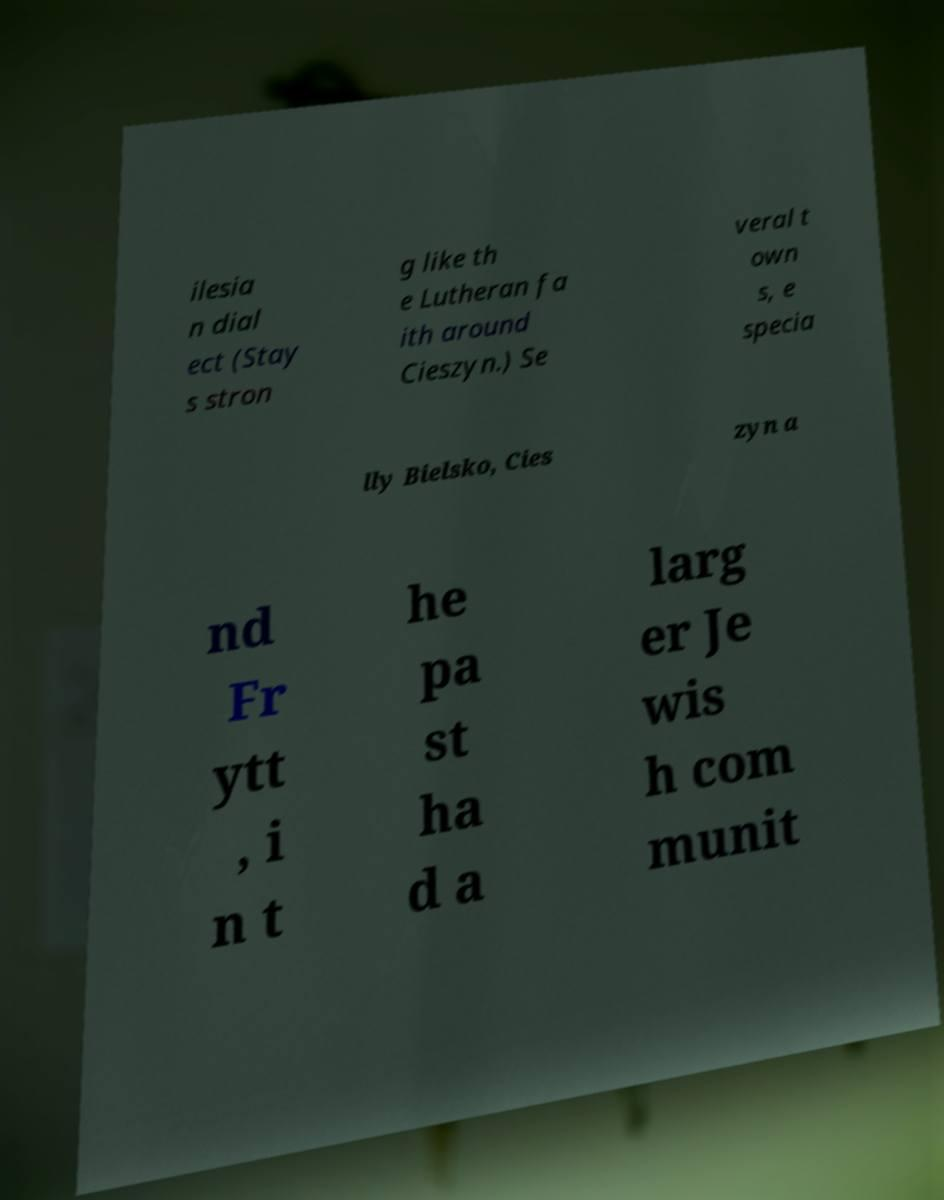There's text embedded in this image that I need extracted. Can you transcribe it verbatim? ilesia n dial ect (Stay s stron g like th e Lutheran fa ith around Cieszyn.) Se veral t own s, e specia lly Bielsko, Cies zyn a nd Fr ytt , i n t he pa st ha d a larg er Je wis h com munit 